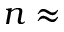Convert formula to latex. <formula><loc_0><loc_0><loc_500><loc_500>n \approx</formula> 